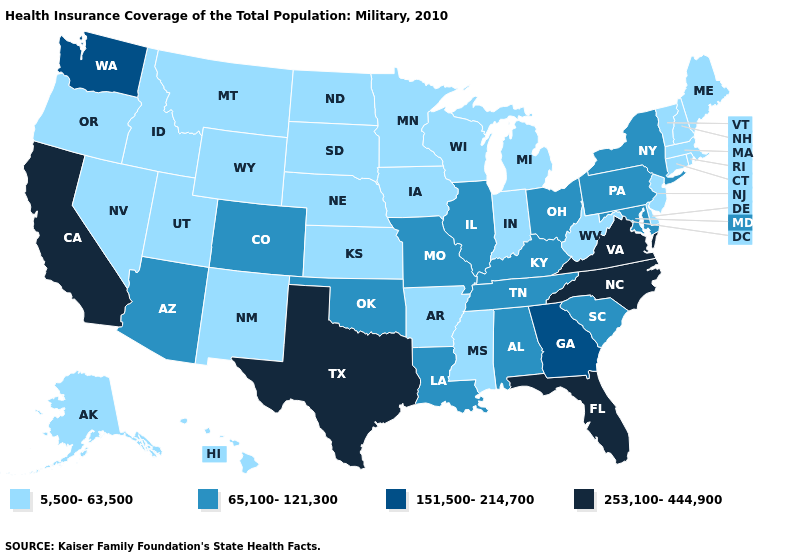Name the states that have a value in the range 5,500-63,500?
Answer briefly. Alaska, Arkansas, Connecticut, Delaware, Hawaii, Idaho, Indiana, Iowa, Kansas, Maine, Massachusetts, Michigan, Minnesota, Mississippi, Montana, Nebraska, Nevada, New Hampshire, New Jersey, New Mexico, North Dakota, Oregon, Rhode Island, South Dakota, Utah, Vermont, West Virginia, Wisconsin, Wyoming. Name the states that have a value in the range 65,100-121,300?
Write a very short answer. Alabama, Arizona, Colorado, Illinois, Kentucky, Louisiana, Maryland, Missouri, New York, Ohio, Oklahoma, Pennsylvania, South Carolina, Tennessee. Does Delaware have the lowest value in the South?
Short answer required. Yes. What is the lowest value in the USA?
Give a very brief answer. 5,500-63,500. Name the states that have a value in the range 253,100-444,900?
Concise answer only. California, Florida, North Carolina, Texas, Virginia. What is the highest value in the South ?
Give a very brief answer. 253,100-444,900. What is the highest value in the USA?
Concise answer only. 253,100-444,900. Does Rhode Island have the lowest value in the USA?
Give a very brief answer. Yes. What is the lowest value in states that border Delaware?
Give a very brief answer. 5,500-63,500. What is the value of South Dakota?
Short answer required. 5,500-63,500. Does Hawaii have the lowest value in the West?
Answer briefly. Yes. Does North Dakota have the highest value in the MidWest?
Give a very brief answer. No. Name the states that have a value in the range 5,500-63,500?
Concise answer only. Alaska, Arkansas, Connecticut, Delaware, Hawaii, Idaho, Indiana, Iowa, Kansas, Maine, Massachusetts, Michigan, Minnesota, Mississippi, Montana, Nebraska, Nevada, New Hampshire, New Jersey, New Mexico, North Dakota, Oregon, Rhode Island, South Dakota, Utah, Vermont, West Virginia, Wisconsin, Wyoming. What is the value of Maryland?
Short answer required. 65,100-121,300. Among the states that border Virginia , does Kentucky have the lowest value?
Answer briefly. No. 